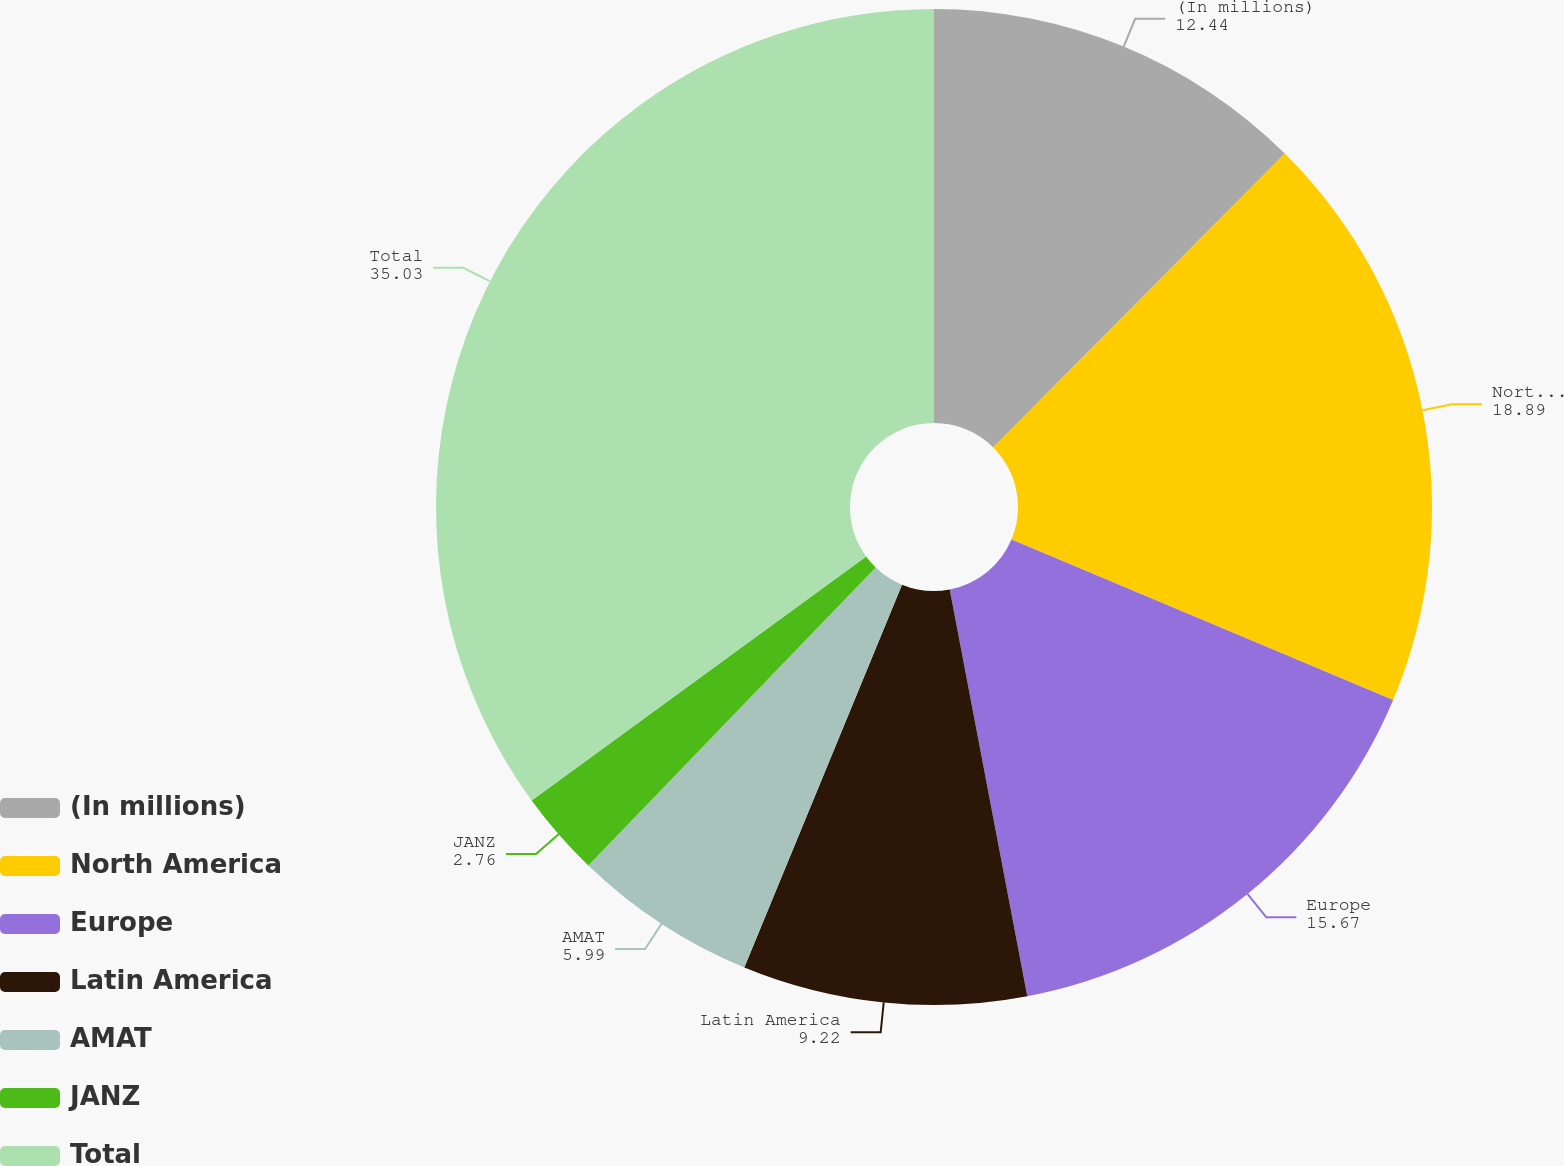Convert chart to OTSL. <chart><loc_0><loc_0><loc_500><loc_500><pie_chart><fcel>(In millions)<fcel>North America<fcel>Europe<fcel>Latin America<fcel>AMAT<fcel>JANZ<fcel>Total<nl><fcel>12.44%<fcel>18.89%<fcel>15.67%<fcel>9.22%<fcel>5.99%<fcel>2.76%<fcel>35.03%<nl></chart> 